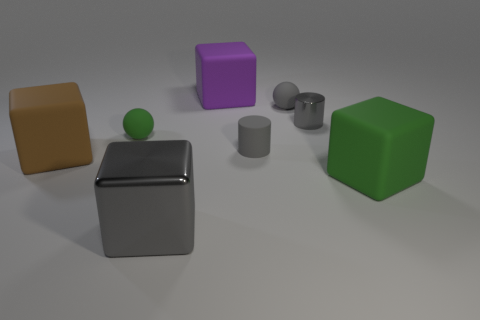What is the material of the gray thing that is left of the large object that is behind the big rubber thing left of the small green matte thing?
Make the answer very short. Metal. What number of gray balls are on the right side of the large cube behind the large brown object?
Your answer should be very brief. 1. What color is the other object that is the same shape as the tiny green rubber thing?
Ensure brevity in your answer.  Gray. Is the material of the purple thing the same as the gray cube?
Make the answer very short. No. How many balls are green objects or big green matte things?
Your answer should be compact. 1. What is the size of the metal object in front of the rubber block that is in front of the big rubber block that is left of the big gray cube?
Give a very brief answer. Large. The metallic object that is the same shape as the large purple matte thing is what size?
Make the answer very short. Large. What number of brown rubber things are right of the tiny green rubber ball?
Offer a very short reply. 0. Does the tiny matte sphere that is in front of the gray metal cylinder have the same color as the matte cylinder?
Make the answer very short. No. What number of yellow objects are big rubber things or small matte balls?
Offer a very short reply. 0. 